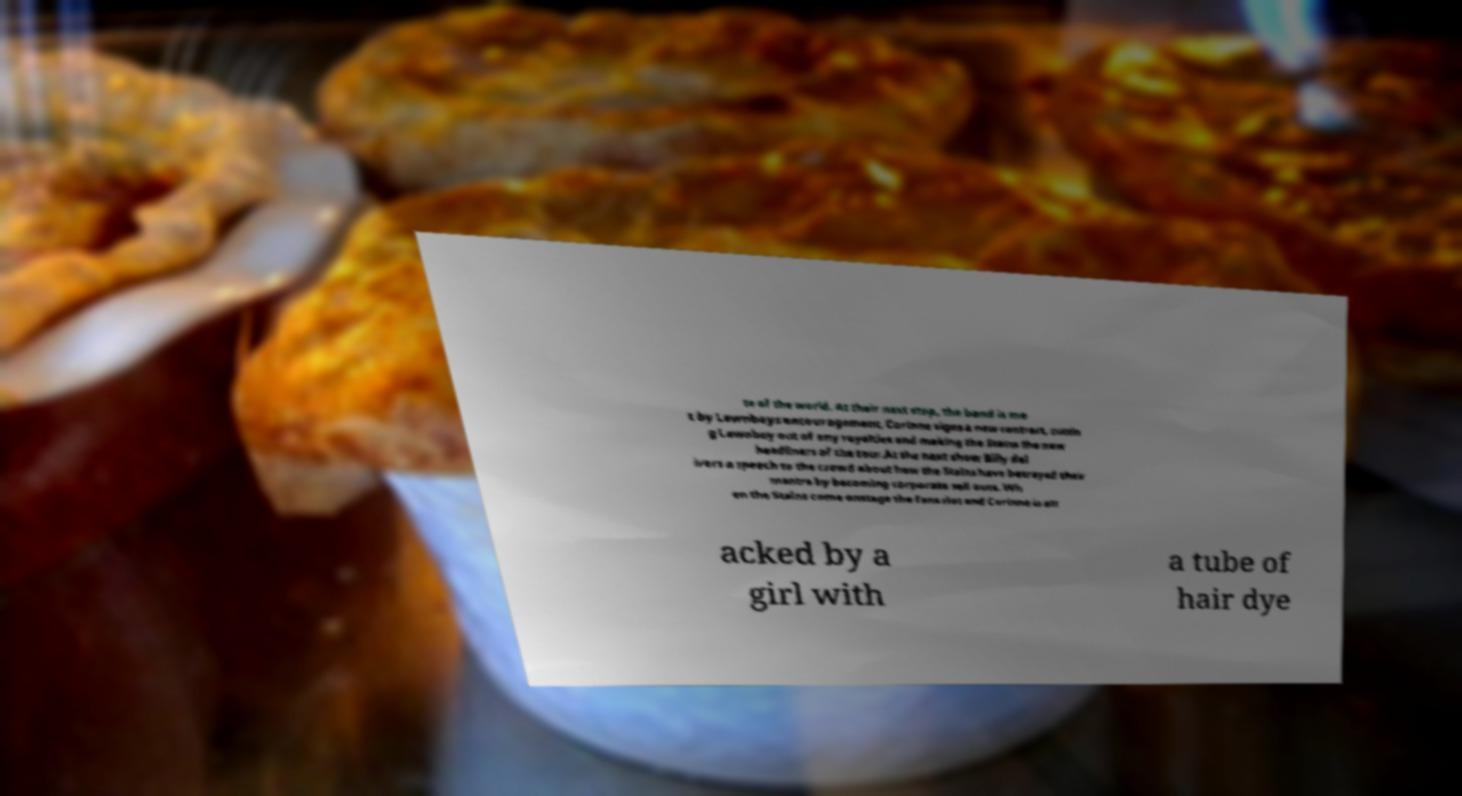For documentation purposes, I need the text within this image transcribed. Could you provide that? te of the world. At their next stop, the band is me t by Lawnboys encouragement, Corinne signs a new contract, cuttin g Lawnboy out of any royalties and making the Stains the new headliners of the tour.At the next show Billy del ivers a speech to the crowd about how the Stains have betrayed their mantra by becoming corporate sell outs. Wh en the Stains come onstage the fans riot and Corinne is att acked by a girl with a tube of hair dye 